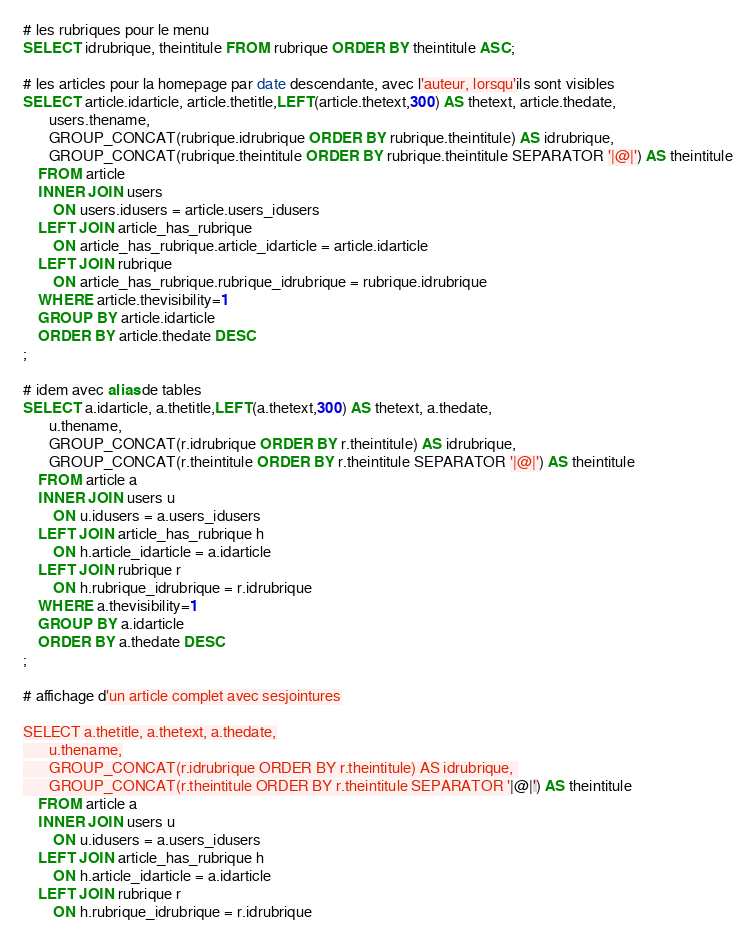Convert code to text. <code><loc_0><loc_0><loc_500><loc_500><_SQL_># les rubriques pour le menu
SELECT idrubrique, theintitule FROM rubrique ORDER BY theintitule ASC;

# les articles pour la homepage par date descendante, avec l'auteur, lorsqu'ils sont visibles
SELECT article.idarticle, article.thetitle,LEFT(article.thetext,300) AS thetext, article.thedate,
	   users.thename,
       GROUP_CONCAT(rubrique.idrubrique ORDER BY rubrique.theintitule) AS idrubrique, 
       GROUP_CONCAT(rubrique.theintitule ORDER BY rubrique.theintitule SEPARATOR '|@|') AS theintitule
	FROM article
    INNER JOIN users
		ON users.idusers = article.users_idusers
    LEFT JOIN article_has_rubrique
		ON article_has_rubrique.article_idarticle = article.idarticle
    LEFT JOIN rubrique
		ON article_has_rubrique.rubrique_idrubrique = rubrique.idrubrique
	WHERE article.thevisibility=1
    GROUP BY article.idarticle
    ORDER BY article.thedate DESC
;

# idem avec alias de tables
SELECT a.idarticle, a.thetitle,LEFT(a.thetext,300) AS thetext, a.thedate,
	   u.thename,
       GROUP_CONCAT(r.idrubrique ORDER BY r.theintitule) AS idrubrique, 
       GROUP_CONCAT(r.theintitule ORDER BY r.theintitule SEPARATOR '|@|') AS theintitule
	FROM article a
    INNER JOIN users u
		ON u.idusers = a.users_idusers
    LEFT JOIN article_has_rubrique h
		ON h.article_idarticle = a.idarticle
    LEFT JOIN rubrique r
		ON h.rubrique_idrubrique = r.idrubrique
	WHERE a.thevisibility=1
    GROUP BY a.idarticle
    ORDER BY a.thedate DESC
;

# affichage d'un article complet avec sesjointures

SELECT a.thetitle, a.thetext, a.thedate,
	   u.thename,
       GROUP_CONCAT(r.idrubrique ORDER BY r.theintitule) AS idrubrique, 
       GROUP_CONCAT(r.theintitule ORDER BY r.theintitule SEPARATOR '|@|') AS theintitule
	FROM article a
    INNER JOIN users u
		ON u.idusers = a.users_idusers
    LEFT JOIN article_has_rubrique h
		ON h.article_idarticle = a.idarticle
    LEFT JOIN rubrique r
		ON h.rubrique_idrubrique = r.idrubrique</code> 